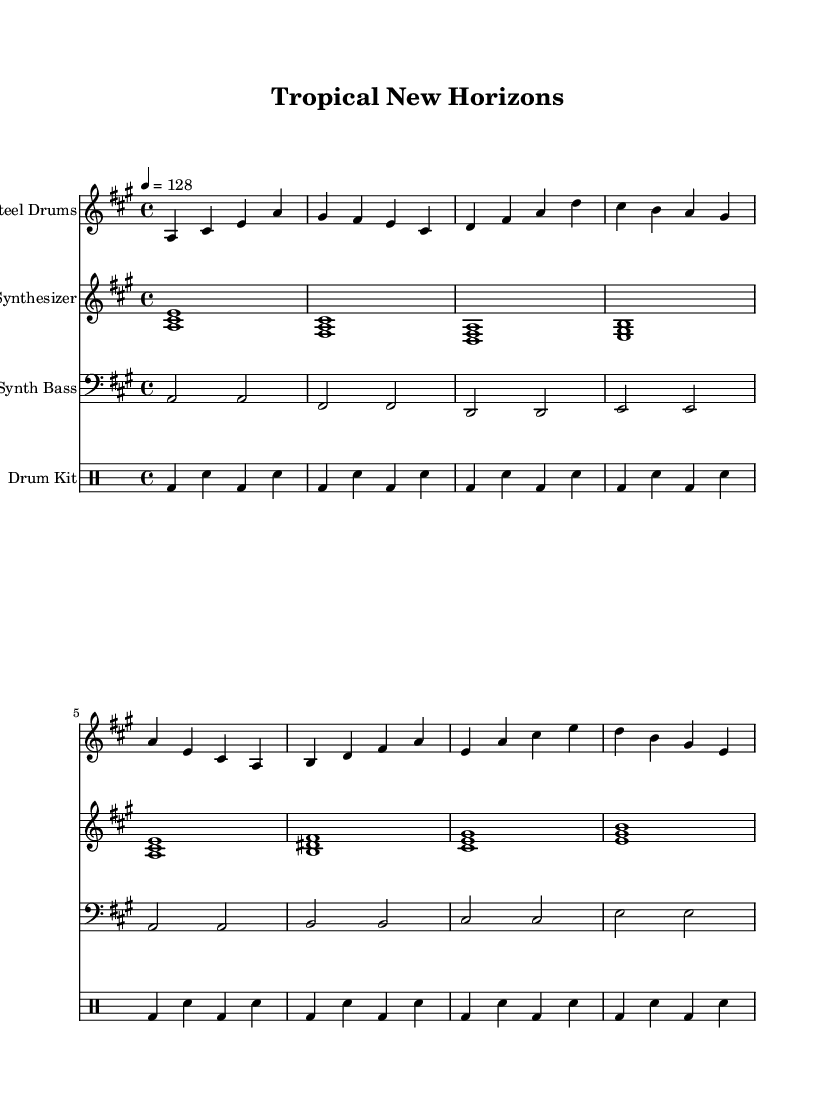What is the key signature of this music? The key signature is A major, which has three sharps (C#, F#, and G#). This can be identified by looking at the key signature indicated at the beginning of the music staff.
Answer: A major What is the time signature of this music? The time signature is 4/4, which indicates four beats per measure and the quarter note gets one beat. This is usually shown at the beginning of the piece.
Answer: 4/4 What is the tempo marking of this music? The tempo marking is 128 beats per minute, indicated by the notation ’4 = 128’. This shows how fast the piece should be played, and it is commonly found below the clef at the start of the score.
Answer: 128 What instruments are featured in this score? The instruments featured are Steel Drums, Synthesizer, Synth Bass, and Drum Kit. Each staff is labeled with the name of the instrument, which can be found at the beginning of each section of the score.
Answer: Steel Drums, Synthesizer, Synth Bass, Drum Kit How many measures are in the Steel Drums section? The Steel Drums section consists of eight measures, which can be counted by looking at the number of vertical lines separating the notes in that staff. Each vertical line denotes the end of a measure.
Answer: 8 What type of dance music is this piece categorized as? This music is categorized as Dance, specifically Tropical-inspired dance pop. This can be inferred from the title "Tropical New Horizons" and the upbeat, celebratory nature of the composition.
Answer: Dance 